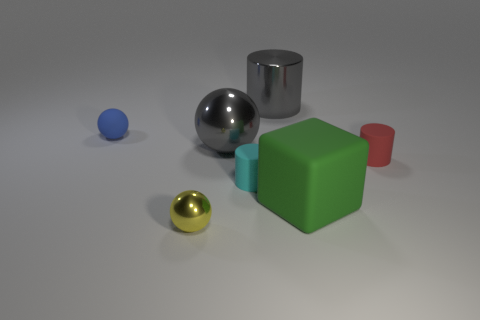There is a shiny ball behind the big green matte object; is it the same color as the metallic cylinder?
Your response must be concise. Yes. How many other objects are there of the same shape as the tiny cyan rubber thing?
Give a very brief answer. 2. The metallic cylinder that is the same color as the large sphere is what size?
Ensure brevity in your answer.  Large. What material is the large thing behind the small rubber object that is behind the big gray metallic ball?
Your response must be concise. Metal. Are there any large gray things in front of the big gray ball?
Keep it short and to the point. No. Is the number of tiny blue spheres that are to the right of the cyan rubber thing greater than the number of green cylinders?
Keep it short and to the point. No. Are there any rubber cylinders that have the same color as the big metal cylinder?
Provide a succinct answer. No. There is another rubber sphere that is the same size as the yellow sphere; what is its color?
Your response must be concise. Blue. Is there a green matte thing behind the sphere that is on the right side of the tiny yellow object?
Ensure brevity in your answer.  No. There is a sphere in front of the large green block; what material is it?
Keep it short and to the point. Metal. 